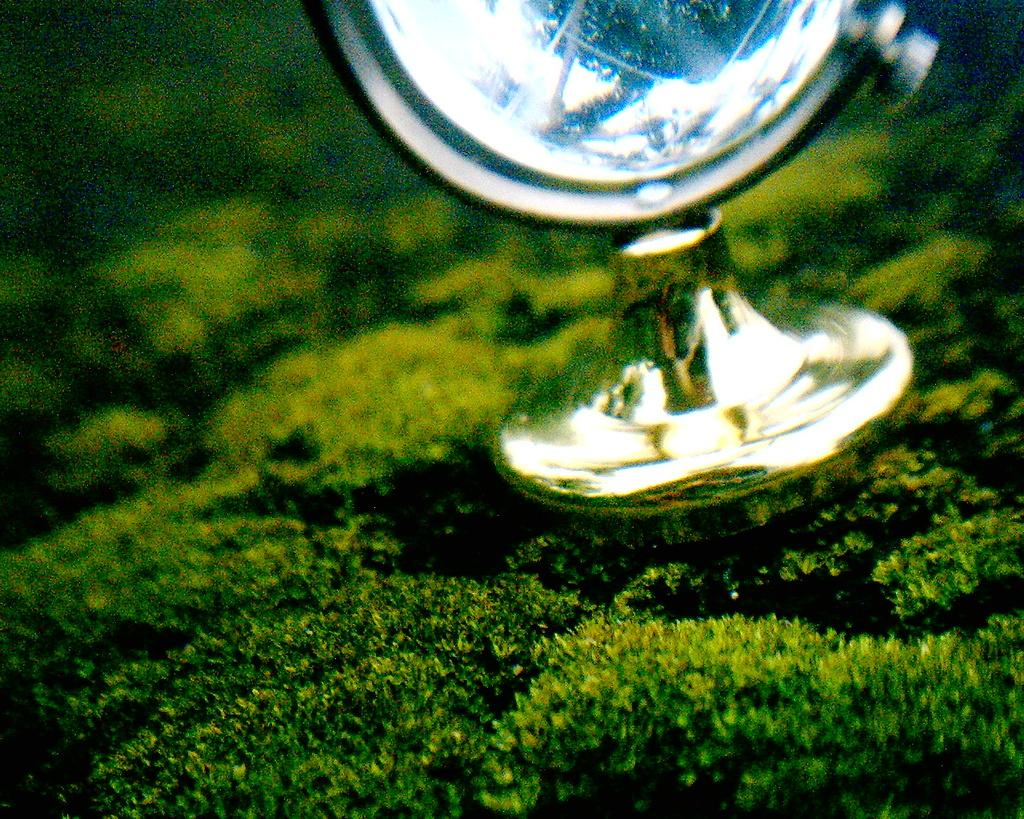What type of material is the object in the image made of? There is a metal object in the image. What color is present in the image? There is something in green color in the image. What is the chance of winning a prize in the image? There is no indication of a prize or a chance to win in the image. What type of fruit can be seen hanging from the metal object in the image? There is no fruit present in the image, and the metal object is not depicted as having any fruit hanging from it. 